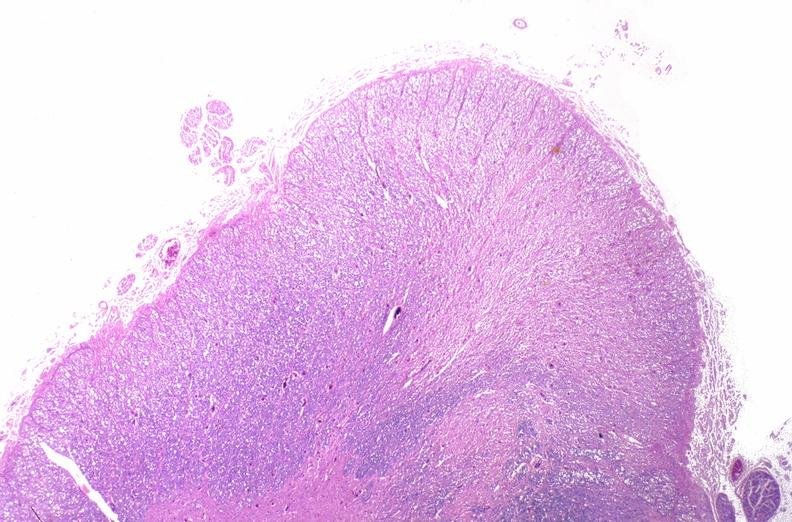why does this image show spinal cord injury?
Answer the question using a single word or phrase. Due to vertebral column trauma 